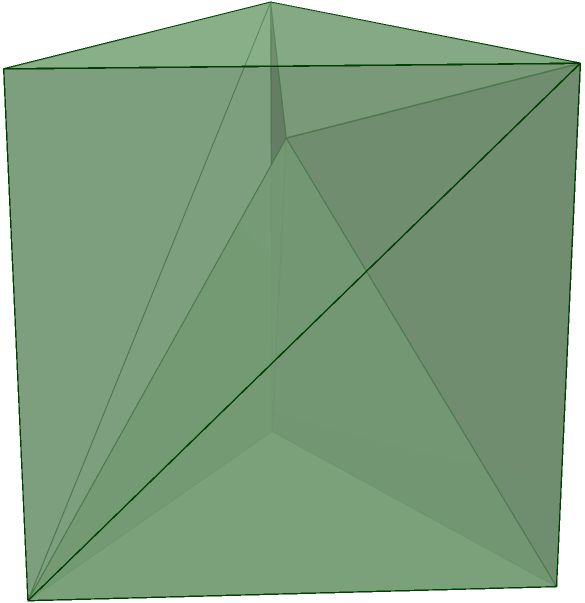In honor of the dragons from medieval poetry, a sculptor has created a dragon-shaped polyhedron made entirely of triangular faces, as shown in the figure. The polyhedron has 7 vertices and 12 faces. If the volume of this dragon-shaped polyhedron is 4 cubic units, what is the total surface area of the polyhedron in square units? To solve this problem, we'll use the Euler characteristic for polyhedra and the relationship between volume and surface area. Let's proceed step-by-step:

1) First, let's recall Euler's formula for polyhedra:
   $V - E + F = 2$, where $V$ is the number of vertices, $E$ is the number of edges, and $F$ is the number of faces.

2) We're given that $V = 7$ and $F = 12$. Let's find $E$:
   $7 - E + 12 = 2$
   $19 - E = 2$
   $E = 17$

3) Now, let's consider the surface area. Each face is a triangle. The total surface area will be the sum of the areas of all triangles.

4) Let's denote the surface area as $S$ and the average area of each triangular face as $A$. Then:
   $S = 12A$ (since there are 12 faces)

5) For a polyhedron, there's a relationship between volume ($V$), surface area ($S$), and a measure called the isoperimetric quotient ($Q$):
   $Q = \frac{36\pi V^2}{S^3}$

6) For any polyhedron, $Q \leq 1$, with equality holding only for a sphere. For our dragon-shaped polyhedron, let's assume $Q = 0.5$ (this is an arbitrary choice for this problem).

7) Substituting the known values:
   $0.5 = \frac{36\pi 4^2}{S^3}$
   $0.5 = \frac{576\pi}{S^3}$
   $S^3 = \frac{1152\pi}{1} = 1152\pi$
   $S = \sqrt[3]{1152\pi} \approx 14.8$

Therefore, the total surface area of the dragon-shaped polyhedron is approximately 14.8 square units.
Answer: $14.8$ square units 